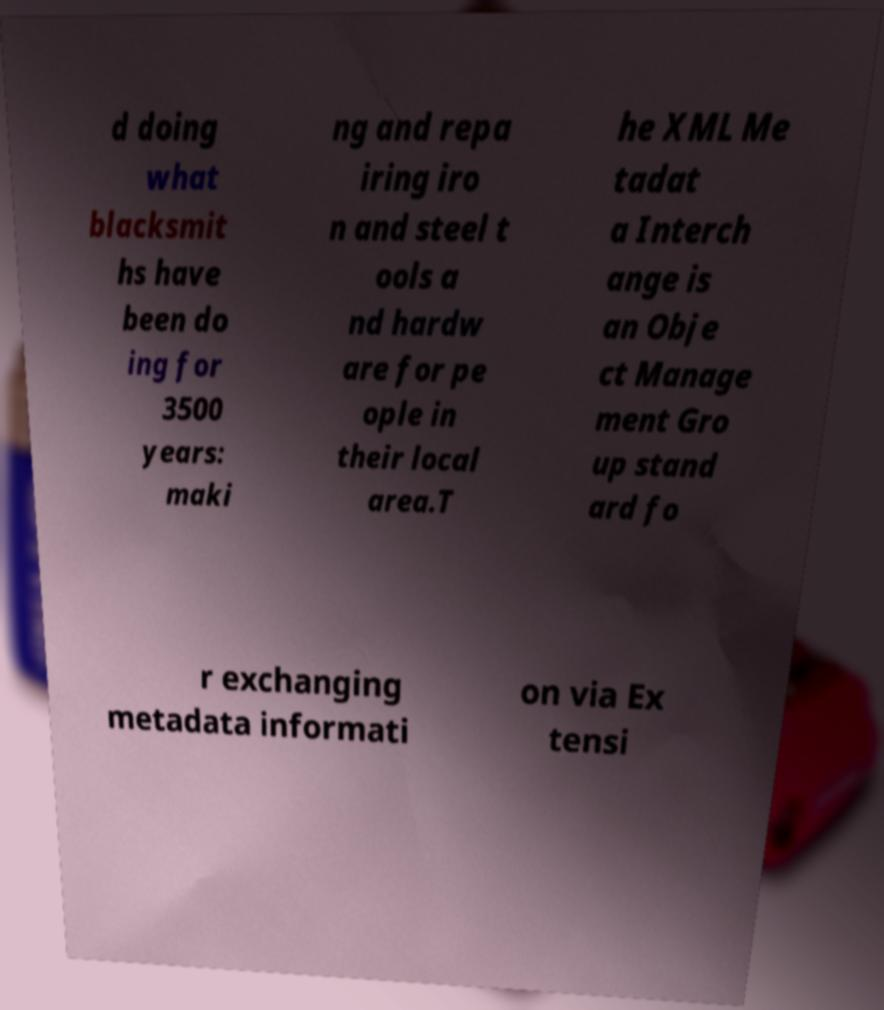For documentation purposes, I need the text within this image transcribed. Could you provide that? d doing what blacksmit hs have been do ing for 3500 years: maki ng and repa iring iro n and steel t ools a nd hardw are for pe ople in their local area.T he XML Me tadat a Interch ange is an Obje ct Manage ment Gro up stand ard fo r exchanging metadata informati on via Ex tensi 